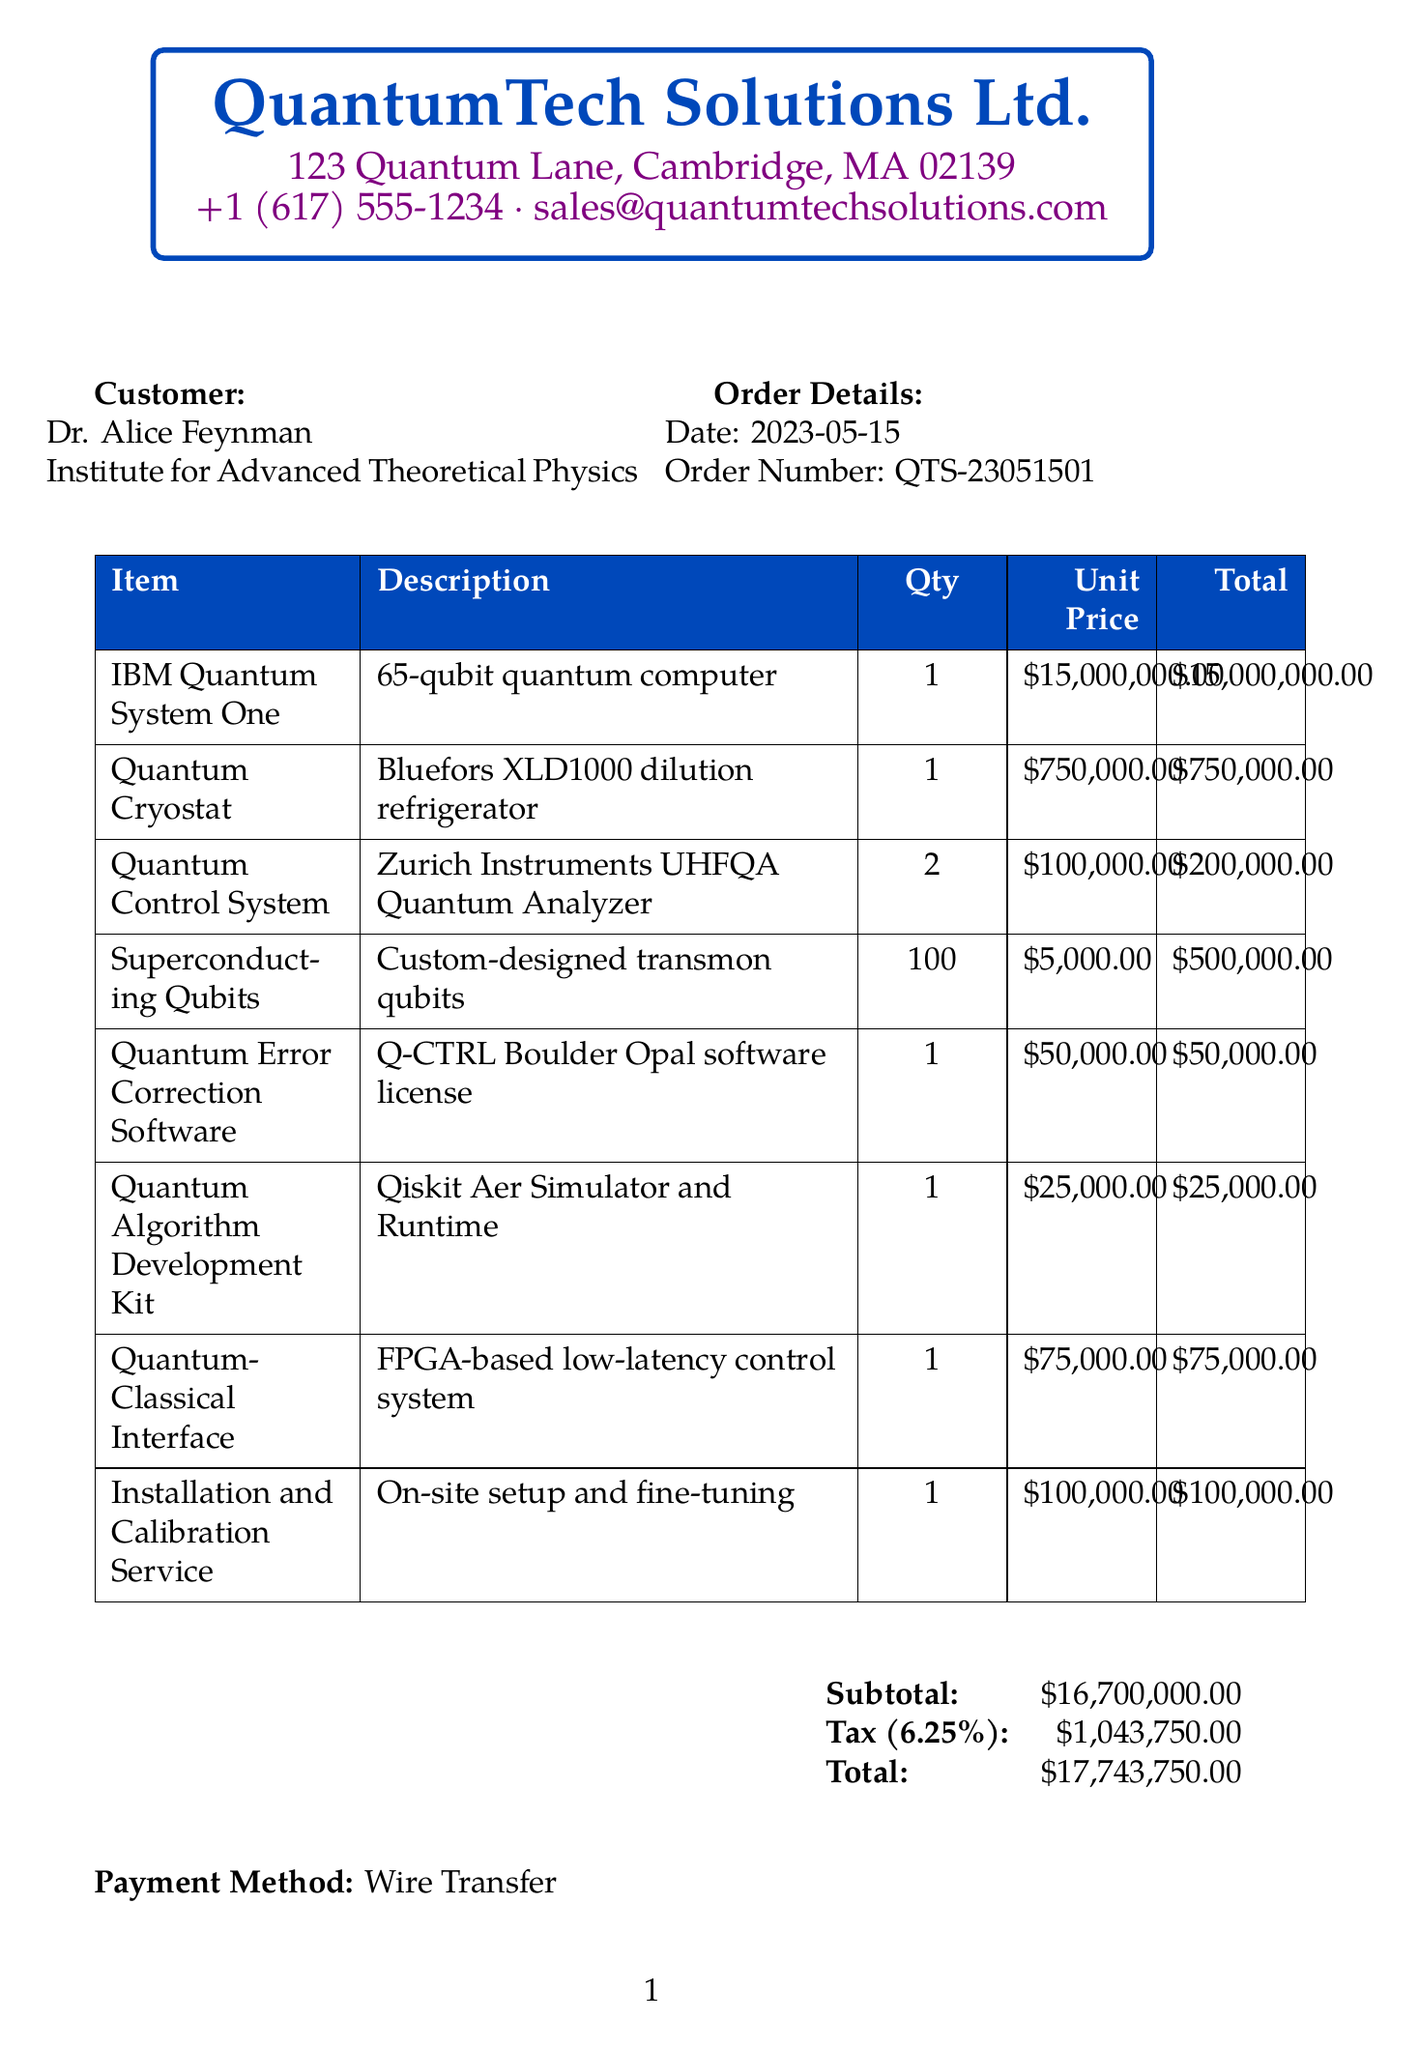What is the date of the order? The date of the order is specified in the document.
Answer: 2023-05-15 Who is the customer? The customer is mentioned at the top of the receipt.
Answer: Dr. Alice Feynman What is the unit price of the IBM Quantum System One? The unit price for the IBM Quantum System One is detailed in the itemized list.
Answer: $15,000,000.00 How many Quantum Control Systems were purchased? The quantity of Quantum Control Systems is provided in the item list.
Answer: 2 What is the total amount of tax charged? The tax amount is calculated and shown in the financial summary.
Answer: $1,043,750.00 What is the subtotal of the order? The subtotal is the sum of all the item prices before tax, which is explicitly stated.
Answer: $16,700,000.00 What is noted about the research potential of the quantum computing setup? The notes section contains details about the research capabilities enabled by the equipment.
Answer: Groundbreaking research in quantum error correction What is the payment method used? The payment method is clearly indicated in the receipt.
Answer: Wire Transfer What is the quantity of Superconducting Qubits purchased? The quantity for Superconducting Qubits is mentioned in the itemized list.
Answer: 100 